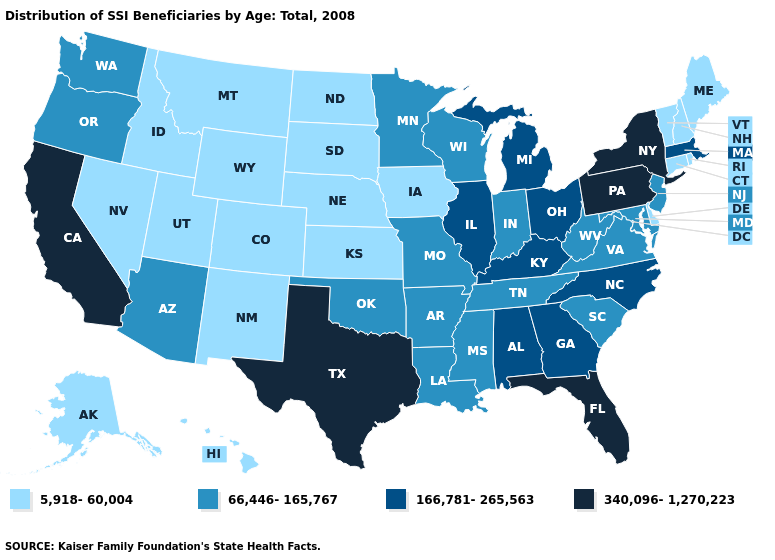What is the highest value in the USA?
Keep it brief. 340,096-1,270,223. What is the lowest value in the South?
Short answer required. 5,918-60,004. Among the states that border Tennessee , does Georgia have the highest value?
Answer briefly. Yes. Does Massachusetts have the highest value in the Northeast?
Give a very brief answer. No. Does Ohio have the highest value in the MidWest?
Write a very short answer. Yes. What is the value of New Jersey?
Give a very brief answer. 66,446-165,767. What is the value of Nebraska?
Keep it brief. 5,918-60,004. Does California have the highest value in the West?
Answer briefly. Yes. Does New Jersey have a higher value than Missouri?
Write a very short answer. No. What is the lowest value in the MidWest?
Concise answer only. 5,918-60,004. Name the states that have a value in the range 166,781-265,563?
Write a very short answer. Alabama, Georgia, Illinois, Kentucky, Massachusetts, Michigan, North Carolina, Ohio. What is the value of Utah?
Write a very short answer. 5,918-60,004. Does the map have missing data?
Write a very short answer. No. 